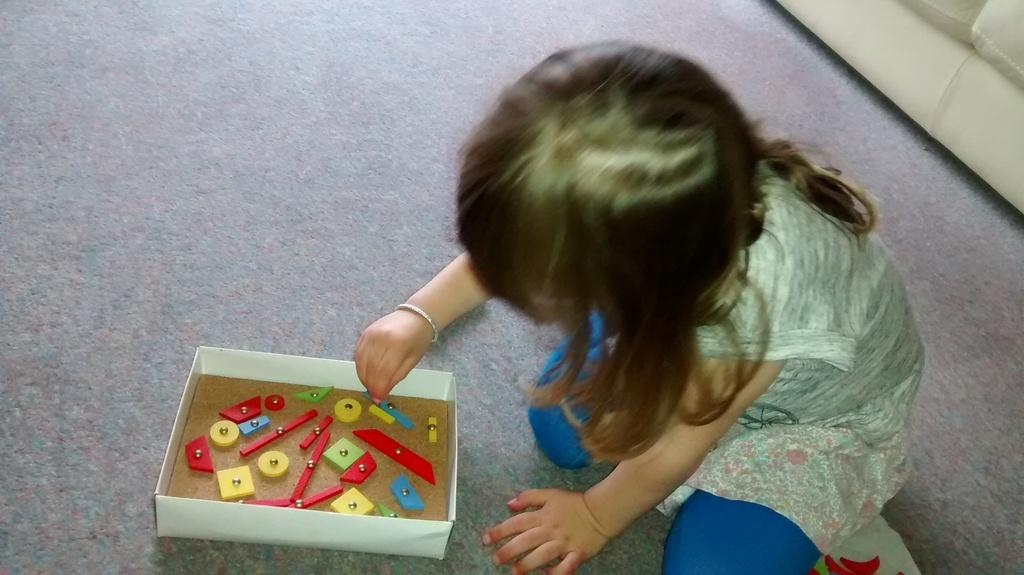Who is the main subject in the image? There is a girl in the image. What is the girl doing in the image? The girl is sitting on the carpet and playing with toys. Where are the toys located when not in use? The toys are in a box. What can be seen in the background of the image? There is a couch in the background of the image, and it is on the carpet. What type of whip is the girl using to play with the toys in the image? There is no whip present in the image; the girl is playing with toys on the carpet. What theory is the girl discussing with the couch in the background of the image? There is no discussion or theory mentioned in the image; the girl is playing with toys, and the couch is in the background. 